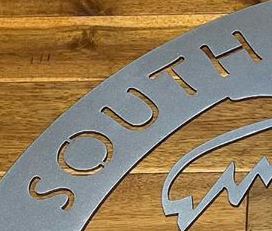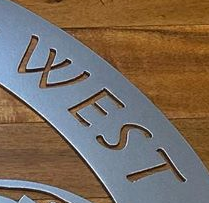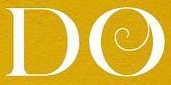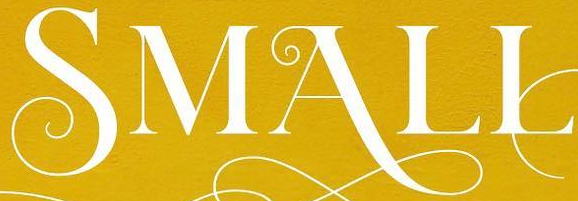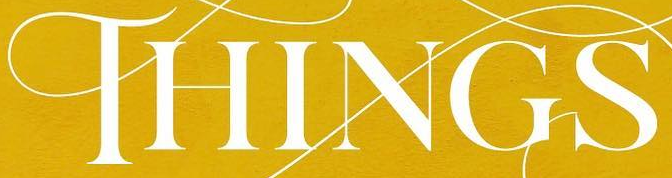What words can you see in these images in sequence, separated by a semicolon? SOUTH; WEST; DO; SMALL; THINGS 